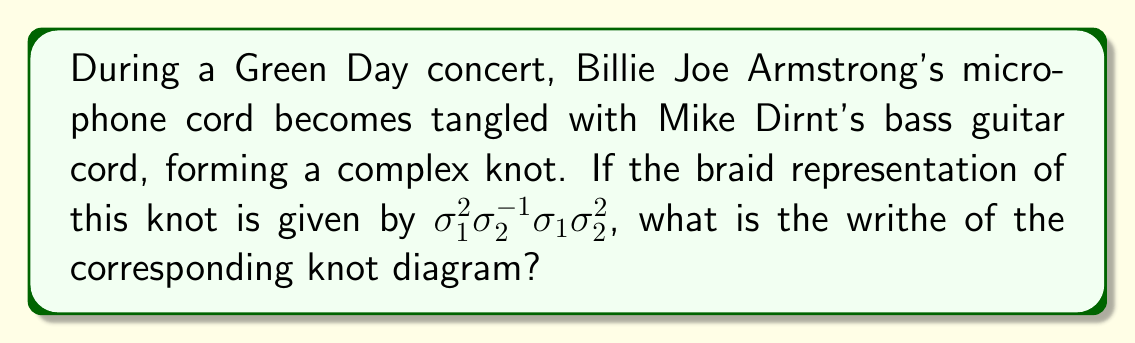Can you solve this math problem? To solve this problem, we'll follow these steps:

1) First, recall that the writhe of a knot diagram is the sum of the signs of all crossings in the diagram.

2) In a braid representation, each $\sigma_i$ corresponds to a positive crossing, while each $\sigma_i^{-1}$ corresponds to a negative crossing.

3) Let's analyze the given braid word $\sigma_1^2\sigma_2^{-1}\sigma_1\sigma_2^2$:

   - $\sigma_1^2$: This represents two positive crossings. Contribution: +2
   - $\sigma_2^{-1}$: This represents one negative crossing. Contribution: -1
   - $\sigma_1$: This represents one positive crossing. Contribution: +1
   - $\sigma_2^2$: This represents two positive crossings. Contribution: +2

4) To calculate the writhe, we sum up all these contributions:

   Writhe = 2 + (-1) + 1 + 2 = 4

Therefore, the writhe of the knot diagram corresponding to this braid representation is 4.
Answer: 4 